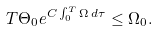Convert formula to latex. <formula><loc_0><loc_0><loc_500><loc_500>T \Theta _ { 0 } e ^ { C \int _ { 0 } ^ { T } \Omega \, d \tau } \leq \Omega _ { 0 } .</formula> 